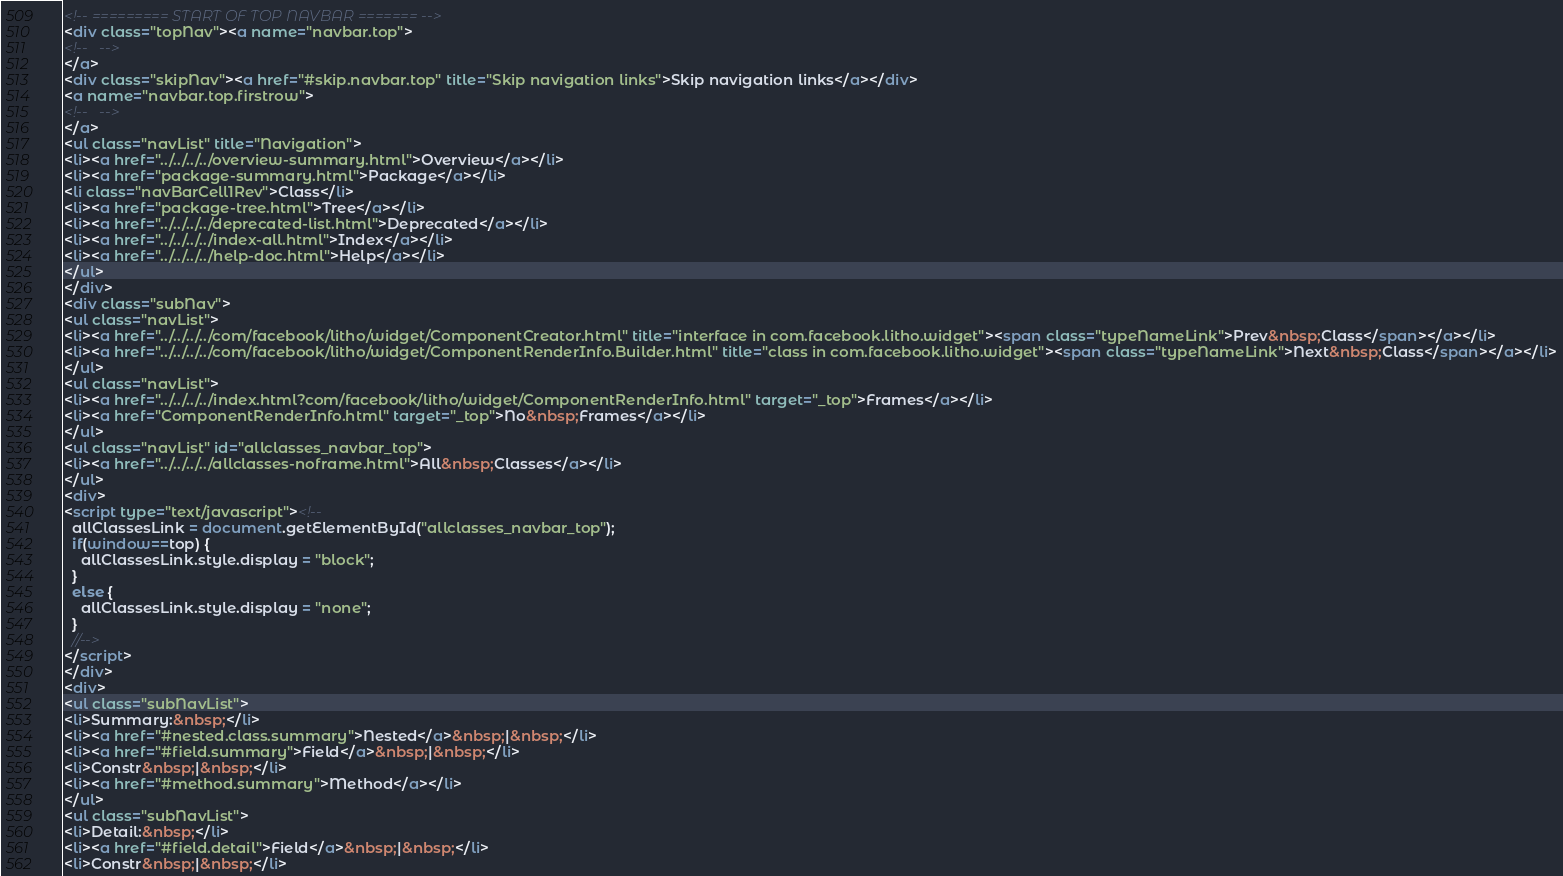<code> <loc_0><loc_0><loc_500><loc_500><_HTML_><!-- ========= START OF TOP NAVBAR ======= -->
<div class="topNav"><a name="navbar.top">
<!--   -->
</a>
<div class="skipNav"><a href="#skip.navbar.top" title="Skip navigation links">Skip navigation links</a></div>
<a name="navbar.top.firstrow">
<!--   -->
</a>
<ul class="navList" title="Navigation">
<li><a href="../../../../overview-summary.html">Overview</a></li>
<li><a href="package-summary.html">Package</a></li>
<li class="navBarCell1Rev">Class</li>
<li><a href="package-tree.html">Tree</a></li>
<li><a href="../../../../deprecated-list.html">Deprecated</a></li>
<li><a href="../../../../index-all.html">Index</a></li>
<li><a href="../../../../help-doc.html">Help</a></li>
</ul>
</div>
<div class="subNav">
<ul class="navList">
<li><a href="../../../../com/facebook/litho/widget/ComponentCreator.html" title="interface in com.facebook.litho.widget"><span class="typeNameLink">Prev&nbsp;Class</span></a></li>
<li><a href="../../../../com/facebook/litho/widget/ComponentRenderInfo.Builder.html" title="class in com.facebook.litho.widget"><span class="typeNameLink">Next&nbsp;Class</span></a></li>
</ul>
<ul class="navList">
<li><a href="../../../../index.html?com/facebook/litho/widget/ComponentRenderInfo.html" target="_top">Frames</a></li>
<li><a href="ComponentRenderInfo.html" target="_top">No&nbsp;Frames</a></li>
</ul>
<ul class="navList" id="allclasses_navbar_top">
<li><a href="../../../../allclasses-noframe.html">All&nbsp;Classes</a></li>
</ul>
<div>
<script type="text/javascript"><!--
  allClassesLink = document.getElementById("allclasses_navbar_top");
  if(window==top) {
    allClassesLink.style.display = "block";
  }
  else {
    allClassesLink.style.display = "none";
  }
  //-->
</script>
</div>
<div>
<ul class="subNavList">
<li>Summary:&nbsp;</li>
<li><a href="#nested.class.summary">Nested</a>&nbsp;|&nbsp;</li>
<li><a href="#field.summary">Field</a>&nbsp;|&nbsp;</li>
<li>Constr&nbsp;|&nbsp;</li>
<li><a href="#method.summary">Method</a></li>
</ul>
<ul class="subNavList">
<li>Detail:&nbsp;</li>
<li><a href="#field.detail">Field</a>&nbsp;|&nbsp;</li>
<li>Constr&nbsp;|&nbsp;</li></code> 